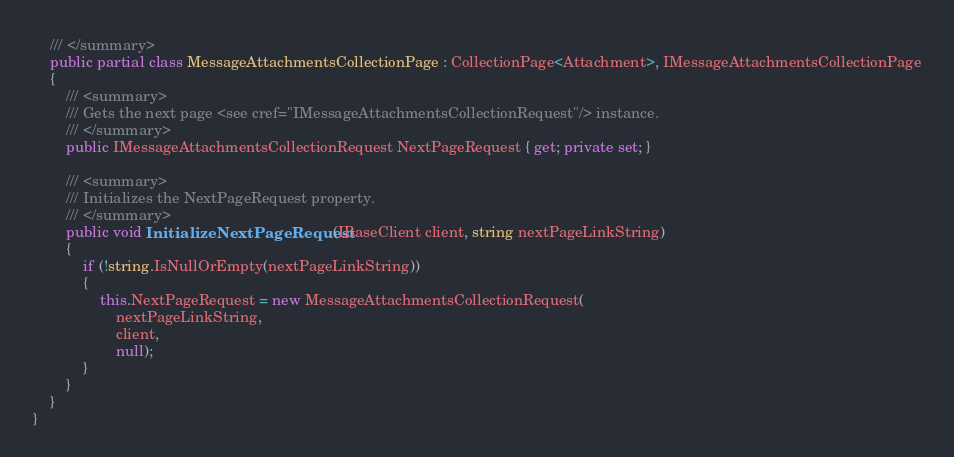<code> <loc_0><loc_0><loc_500><loc_500><_C#_>    /// </summary>
    public partial class MessageAttachmentsCollectionPage : CollectionPage<Attachment>, IMessageAttachmentsCollectionPage
    {
        /// <summary>
        /// Gets the next page <see cref="IMessageAttachmentsCollectionRequest"/> instance.
        /// </summary>
        public IMessageAttachmentsCollectionRequest NextPageRequest { get; private set; }

        /// <summary>
        /// Initializes the NextPageRequest property.
        /// </summary>
        public void InitializeNextPageRequest(IBaseClient client, string nextPageLinkString)
        {
            if (!string.IsNullOrEmpty(nextPageLinkString))
            {
                this.NextPageRequest = new MessageAttachmentsCollectionRequest(
                    nextPageLinkString,
                    client,
                    null);
            }
        }
    }
}
</code> 